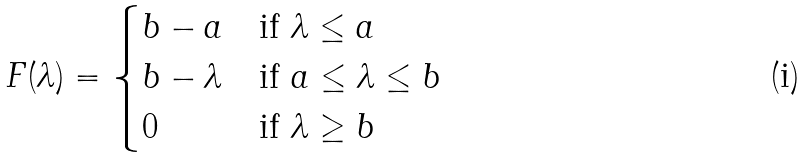Convert formula to latex. <formula><loc_0><loc_0><loc_500><loc_500>F ( \lambda ) = \begin{cases} b - a & \text {if } \lambda \leq a \\ b - \lambda & \text {if } a \leq \lambda \leq b \\ 0 & \text {if } \lambda \geq b \end{cases}</formula> 